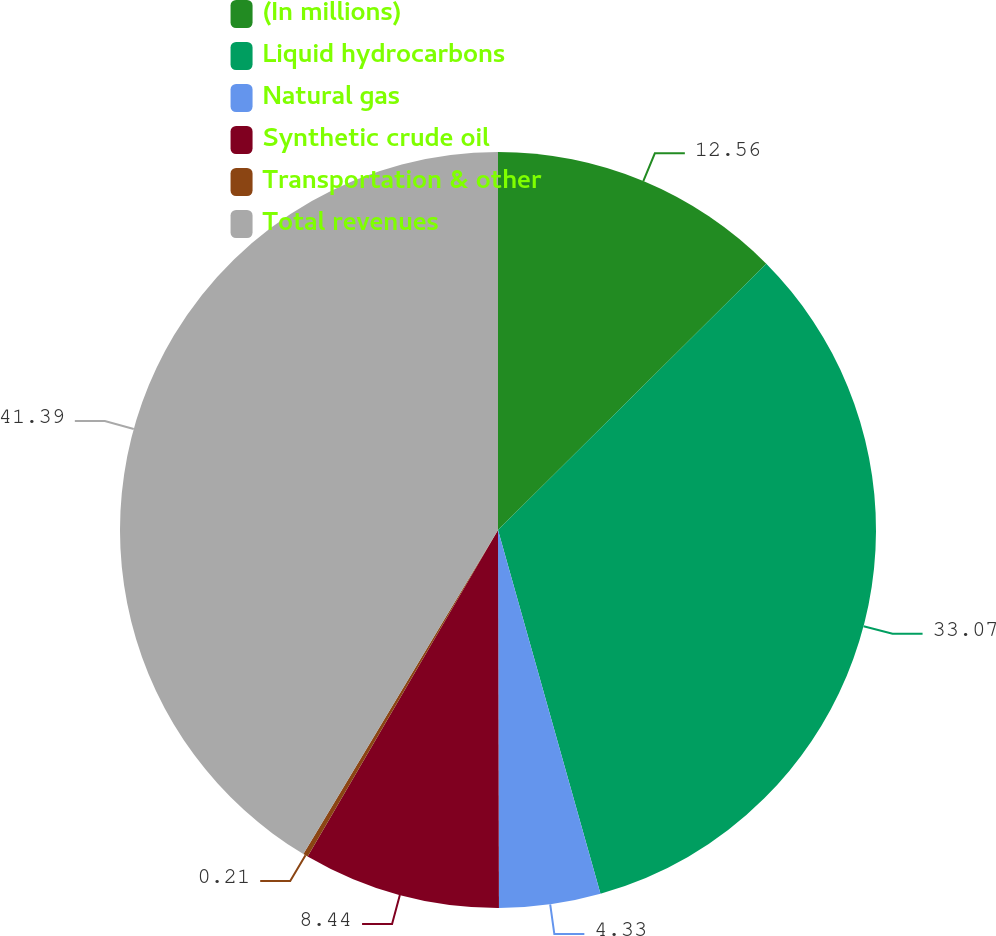Convert chart to OTSL. <chart><loc_0><loc_0><loc_500><loc_500><pie_chart><fcel>(In millions)<fcel>Liquid hydrocarbons<fcel>Natural gas<fcel>Synthetic crude oil<fcel>Transportation & other<fcel>Total revenues<nl><fcel>12.56%<fcel>33.07%<fcel>4.33%<fcel>8.44%<fcel>0.21%<fcel>41.39%<nl></chart> 